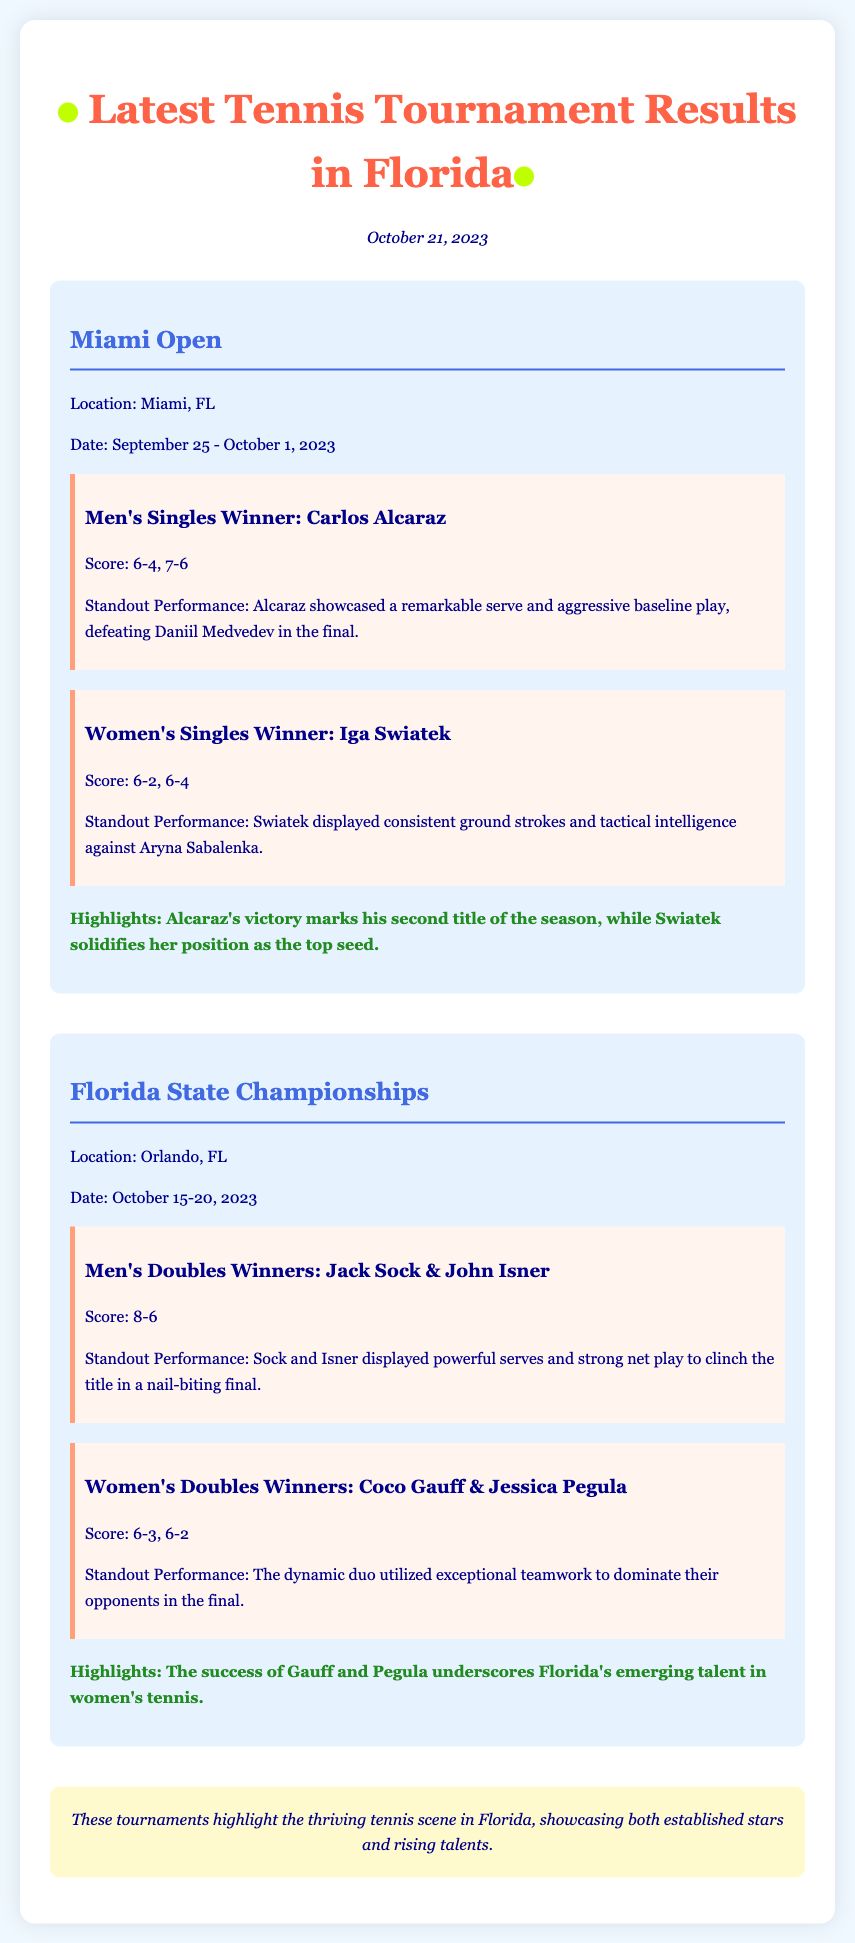What was the date of the Miami Open? The Miami Open took place from September 25 to October 1, 2023.
Answer: September 25 - October 1, 2023 Who won the Women's Singles at the Miami Open? The Women's Singles winner at the Miami Open was Iga Swiatek.
Answer: Iga Swiatek What was the score of the Men's Singles final? The score of the Men's Singles final was 6-4, 7-6.
Answer: 6-4, 7-6 Which players won the Men's Doubles in the Florida State Championships? The Men's Doubles winners were Jack Sock and John Isner.
Answer: Jack Sock & John Isner What highlight emphasized the success of Gauff and Pegula? The highlight mentioned that their success underscores Florida's emerging talent in women's tennis.
Answer: Florida's emerging talent in women's tennis What does Carlos Alcaraz's victory mark in terms of titles this season? Carlos Alcaraz's victory marks his second title of the season.
Answer: Second title of the season What outstanding quality did Iga Swiatek display in her final match? Iga Swiatek displayed consistent ground strokes and tactical intelligence.
Answer: Consistent ground strokes and tactical intelligence What was the score of the Women's Doubles final? The score of the Women's Doubles final was 6-3, 6-2.
Answer: 6-3, 6-2 What is the overall conclusion about the tennis scene in Florida? The conclusion states that these tournaments highlight the thriving tennis scene in Florida.
Answer: Thriving tennis scene in Florida 